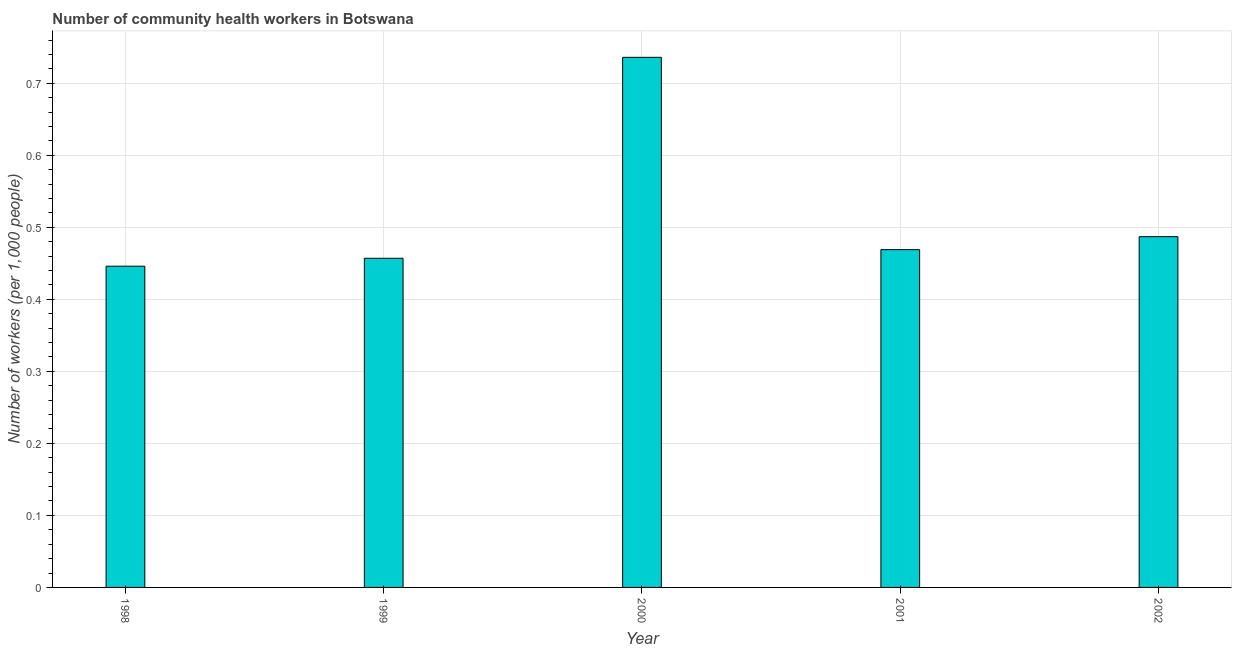Does the graph contain any zero values?
Your answer should be very brief. No. What is the title of the graph?
Give a very brief answer. Number of community health workers in Botswana. What is the label or title of the X-axis?
Ensure brevity in your answer.  Year. What is the label or title of the Y-axis?
Your response must be concise. Number of workers (per 1,0 people). What is the number of community health workers in 1999?
Give a very brief answer. 0.46. Across all years, what is the maximum number of community health workers?
Provide a short and direct response. 0.74. Across all years, what is the minimum number of community health workers?
Provide a short and direct response. 0.45. In which year was the number of community health workers minimum?
Give a very brief answer. 1998. What is the sum of the number of community health workers?
Your response must be concise. 2.6. What is the difference between the number of community health workers in 1998 and 2000?
Your answer should be very brief. -0.29. What is the average number of community health workers per year?
Provide a short and direct response. 0.52. What is the median number of community health workers?
Your response must be concise. 0.47. Do a majority of the years between 1998 and 2001 (inclusive) have number of community health workers greater than 0.3 ?
Provide a succinct answer. Yes. What is the ratio of the number of community health workers in 1999 to that in 2000?
Provide a succinct answer. 0.62. Is the number of community health workers in 1999 less than that in 2001?
Provide a succinct answer. Yes. Is the difference between the number of community health workers in 1998 and 2001 greater than the difference between any two years?
Your response must be concise. No. What is the difference between the highest and the second highest number of community health workers?
Your response must be concise. 0.25. What is the difference between the highest and the lowest number of community health workers?
Give a very brief answer. 0.29. How many bars are there?
Offer a terse response. 5. How many years are there in the graph?
Provide a short and direct response. 5. Are the values on the major ticks of Y-axis written in scientific E-notation?
Offer a very short reply. No. What is the Number of workers (per 1,000 people) of 1998?
Make the answer very short. 0.45. What is the Number of workers (per 1,000 people) in 1999?
Your answer should be compact. 0.46. What is the Number of workers (per 1,000 people) in 2000?
Make the answer very short. 0.74. What is the Number of workers (per 1,000 people) in 2001?
Provide a succinct answer. 0.47. What is the Number of workers (per 1,000 people) in 2002?
Offer a terse response. 0.49. What is the difference between the Number of workers (per 1,000 people) in 1998 and 1999?
Ensure brevity in your answer.  -0.01. What is the difference between the Number of workers (per 1,000 people) in 1998 and 2000?
Offer a terse response. -0.29. What is the difference between the Number of workers (per 1,000 people) in 1998 and 2001?
Ensure brevity in your answer.  -0.02. What is the difference between the Number of workers (per 1,000 people) in 1998 and 2002?
Your response must be concise. -0.04. What is the difference between the Number of workers (per 1,000 people) in 1999 and 2000?
Your answer should be compact. -0.28. What is the difference between the Number of workers (per 1,000 people) in 1999 and 2001?
Offer a terse response. -0.01. What is the difference between the Number of workers (per 1,000 people) in 1999 and 2002?
Give a very brief answer. -0.03. What is the difference between the Number of workers (per 1,000 people) in 2000 and 2001?
Provide a succinct answer. 0.27. What is the difference between the Number of workers (per 1,000 people) in 2000 and 2002?
Make the answer very short. 0.25. What is the difference between the Number of workers (per 1,000 people) in 2001 and 2002?
Keep it short and to the point. -0.02. What is the ratio of the Number of workers (per 1,000 people) in 1998 to that in 2000?
Ensure brevity in your answer.  0.61. What is the ratio of the Number of workers (per 1,000 people) in 1998 to that in 2001?
Make the answer very short. 0.95. What is the ratio of the Number of workers (per 1,000 people) in 1998 to that in 2002?
Offer a very short reply. 0.92. What is the ratio of the Number of workers (per 1,000 people) in 1999 to that in 2000?
Your response must be concise. 0.62. What is the ratio of the Number of workers (per 1,000 people) in 1999 to that in 2002?
Offer a very short reply. 0.94. What is the ratio of the Number of workers (per 1,000 people) in 2000 to that in 2001?
Offer a very short reply. 1.57. What is the ratio of the Number of workers (per 1,000 people) in 2000 to that in 2002?
Provide a succinct answer. 1.51. What is the ratio of the Number of workers (per 1,000 people) in 2001 to that in 2002?
Give a very brief answer. 0.96. 